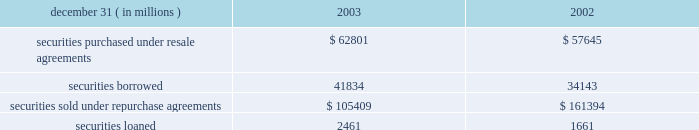Notes to consolidated financial statements j.p .
Morgan chase & co .
98 j.p .
Morgan chase & co .
/ 2003 annual report securities financing activities jpmorgan chase enters into resale agreements , repurchase agreements , securities borrowed transactions and securities loaned transactions primarily to finance the firm 2019s inventory positions , acquire securities to cover short positions and settle other securities obligations .
The firm also enters into these transactions to accommodate customers 2019 needs .
Securities purchased under resale agreements ( 201cresale agreements 201d ) and securities sold under repurchase agreements ( 201crepurchase agreements 201d ) are generally treated as collateralized financing transactions and are carried on the consolidated bal- ance sheet at the amounts the securities will be subsequently sold or repurchased , plus accrued interest .
Where appropriate , resale and repurchase agreements with the same counterparty are reported on a net basis in accordance with fin 41 .
Jpmorgan chase takes possession of securities purchased under resale agreements .
On a daily basis , jpmorgan chase monitors the market value of the underlying collateral received from its counterparties , consisting primarily of u.s .
And non-u.s .
Govern- ment and agency securities , and requests additional collateral from its counterparties when necessary .
Similar transactions that do not meet the sfas 140 definition of a repurchase agreement are accounted for as 201cbuys 201d and 201csells 201d rather than financing transactions .
These transactions are accounted for as a purchase ( sale ) of the underlying securities with a forward obligation to sell ( purchase ) the securities .
The forward purchase ( sale ) obligation , a derivative , is recorded on the consolidated balance sheet at its fair value , with changes in fair value recorded in trading revenue .
Notional amounts of these transactions accounted for as purchases under sfas 140 were $ 15 billion and $ 8 billion at december 31 , 2003 and 2002 , respectively .
Notional amounts of these transactions accounted for as sales under sfas 140 were $ 8 billion and $ 13 billion at december 31 , 2003 and 2002 , respectively .
Based on the short-term duration of these contracts , the unrealized gain or loss is insignificant .
Securities borrowed and securities lent are recorded at the amount of cash collateral advanced or received .
Securities bor- rowed consist primarily of government and equity securities .
Jpmorgan chase monitors the market value of the securities borrowed and lent on a daily basis and calls for additional col- lateral when appropriate .
Fees received or paid are recorded in interest income or interest expense. .
Note 10 jpmorgan chase pledges certain financial instruments it owns to collateralize repurchase agreements and other securities financ- ings .
Pledged securities that can be sold or repledged by the secured party are identified as financial instruments owned ( pledged to various parties ) on the consolidated balance sheet .
At december 31 , 2003 , the firm had received securities as col- lateral that can be repledged , delivered or otherwise used with a fair value of approximately $ 210 billion .
This collateral was gen- erally obtained under resale or securities-borrowing agreements .
Of these securities , approximately $ 197 billion was repledged , delivered or otherwise used , generally as collateral under repur- chase agreements , securities-lending agreements or to cover short sales .
Notes to consolidated financial statements j.p .
Morgan chase & co .
Loans are reported at the principal amount outstanding , net of the allowance for loan losses , unearned income and any net deferred loan fees .
Loans held for sale are carried at the lower of aggregate cost or fair value .
Loans are classified as 201ctrading 201d for secondary market trading activities where positions are bought and sold to make profits from short-term movements in price .
Loans held for trading purposes are included in trading assets and are carried at fair value , with the gains and losses included in trading revenue .
Interest income is recognized using the interest method , or on a basis approximating a level rate of return over the term of the loan .
Nonaccrual loans are those on which the accrual of interest is discontinued .
Loans ( other than certain consumer loans discussed below ) are placed on nonaccrual status immediately if , in the opinion of management , full payment of principal or interest is in doubt , or when principal or interest is 90 days or more past due and collateral , if any , is insufficient to cover prin- cipal and interest .
Interest accrued but not collected at the date a loan is placed on nonaccrual status is reversed against interest income .
In addition , the amortization of net deferred loan fees is suspended .
Interest income on nonaccrual loans is recognized only to the extent it is received in cash .
However , where there is doubt regarding the ultimate collectibility of loan principal , all cash thereafter received is applied to reduce the carrying value of the loan .
Loans are restored to accrual status only when interest and principal payments are brought current and future payments are reasonably assured .
Consumer loans are generally charged to the allowance for loan losses upon reaching specified stages of delinquency , in accor- dance with the federal financial institutions examination council ( 201cffiec 201d ) policy .
For example , credit card loans are charged off at the earlier of 180 days past due or within 60 days from receiving notification of the filing of bankruptcy .
Residential mortgage products are generally charged off to net realizable value at 180 days past due .
Other consumer products are gener- ally charged off ( to net realizable value if collateralized ) at 120 days past due .
Accrued interest on residential mortgage products , automobile financings and certain other consumer loans are accounted for in accordance with the nonaccrual loan policy note 11 .
What was the ratio of the accounted for as purchases under sfas 14 in 2003 to 2002? 
Computations: (15 / 8)
Answer: 1.875. 